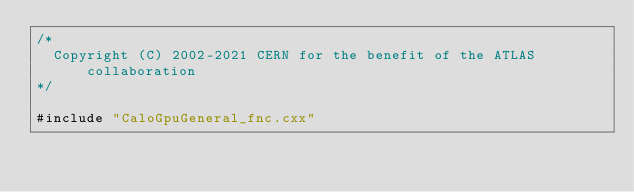Convert code to text. <code><loc_0><loc_0><loc_500><loc_500><_Cuda_>/*
  Copyright (C) 2002-2021 CERN for the benefit of the ATLAS collaboration
*/

#include "CaloGpuGeneral_fnc.cxx"

</code> 